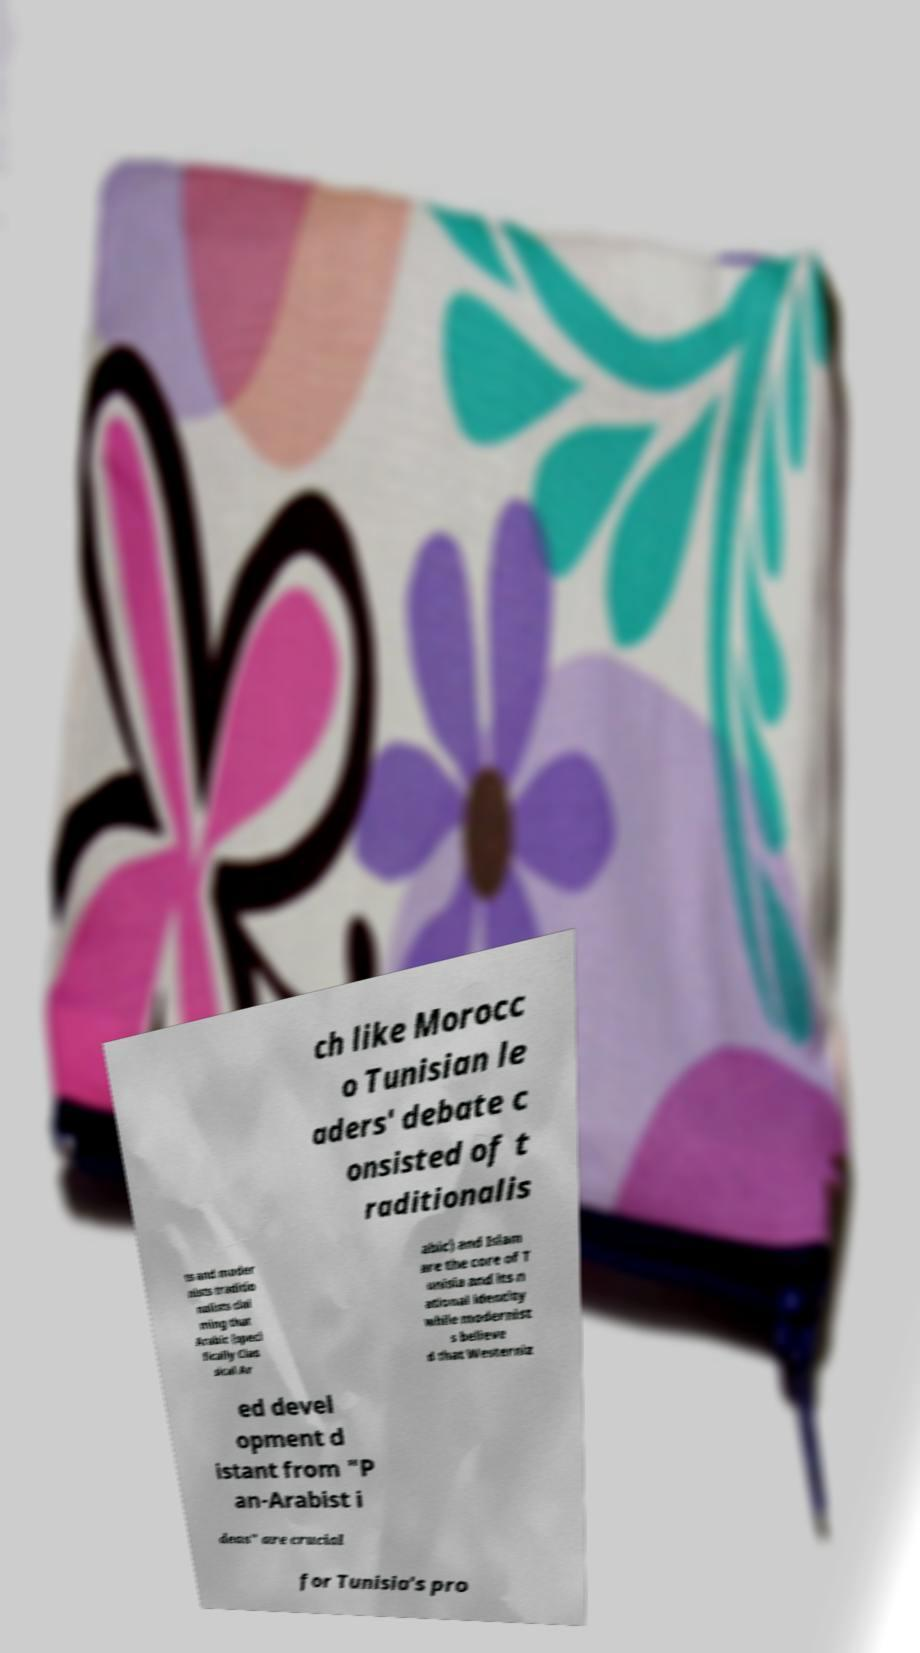There's text embedded in this image that I need extracted. Can you transcribe it verbatim? ch like Morocc o Tunisian le aders' debate c onsisted of t raditionalis ts and moder nists traditio nalists clai ming that Arabic (speci fically Clas sical Ar abic) and Islam are the core of T unisia and its n ational identity while modernist s believe d that Westerniz ed devel opment d istant from "P an-Arabist i deas" are crucial for Tunisia's pro 